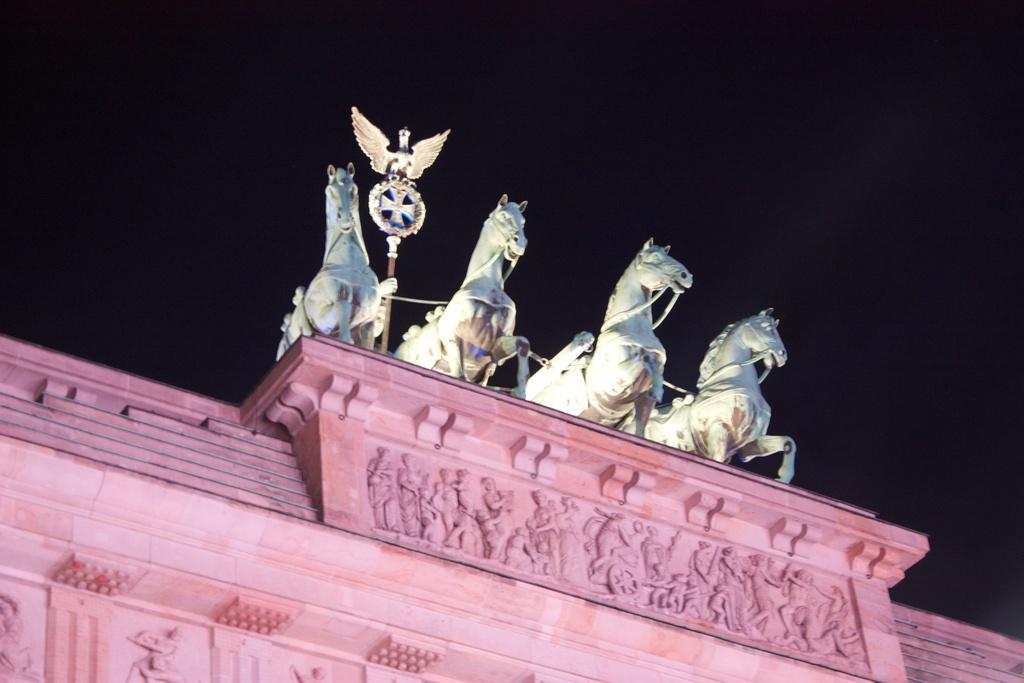Could you give a brief overview of what you see in this image? In the image we can see there is a building and there are statue of horses. 